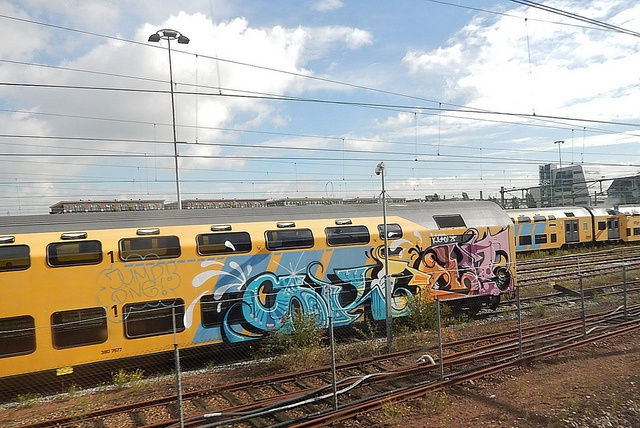Describe the objects in this image and their specific colors. I can see train in darkgray, black, orange, and gray tones and train in darkgray, black, ivory, tan, and gray tones in this image. 